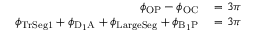Convert formula to latex. <formula><loc_0><loc_0><loc_500><loc_500>\begin{array} { r l } { \phi _ { O P } - \phi _ { O C } } & = 3 \pi } \\ { \phi _ { T r S e g 1 } + \phi _ { D _ { 1 } A } + \phi _ { L \arg e S e g } + \phi _ { B _ { 1 } P } } & = 3 \pi } \end{array}</formula> 